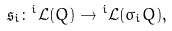Convert formula to latex. <formula><loc_0><loc_0><loc_500><loc_500>\mathfrak { s } _ { i } \colon { ^ { i } \mathcal { L } } ( Q ) \rightarrow { ^ { i } \mathcal { L } } ( \sigma _ { i } Q ) ,</formula> 